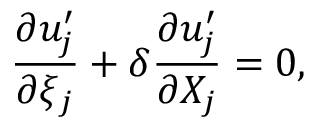Convert formula to latex. <formula><loc_0><loc_0><loc_500><loc_500>\frac { \partial u _ { j } ^ { \prime } } { \partial \xi _ { j } } + \delta \frac { \partial u _ { j } ^ { \prime } } { \partial X _ { j } } = 0 ,</formula> 